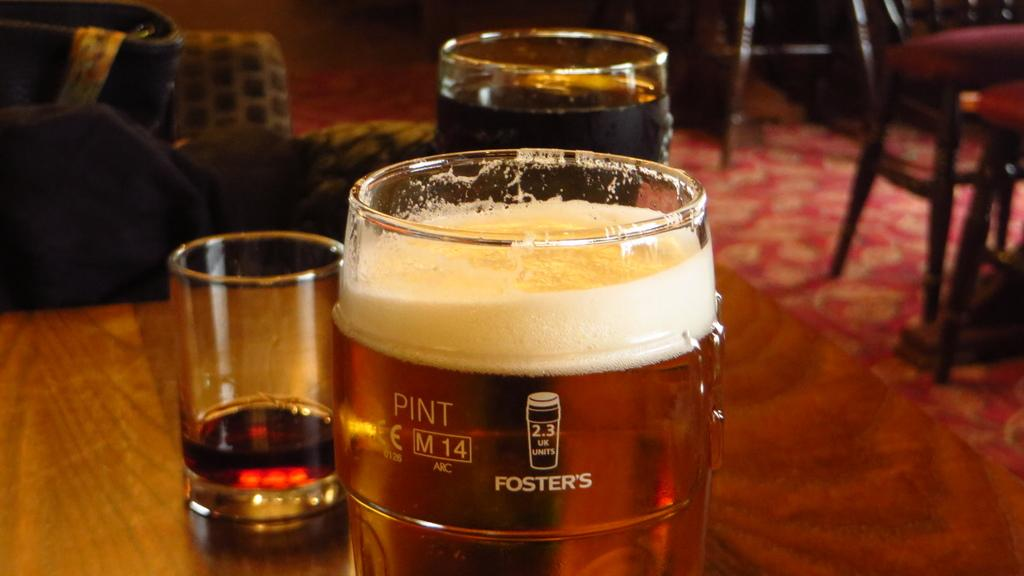Provide a one-sentence caption for the provided image. A pint of beer sitting on a wooden table with two other drinks in glasses in the background. 